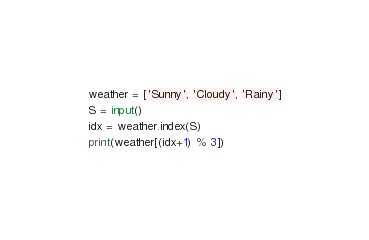<code> <loc_0><loc_0><loc_500><loc_500><_Python_>weather = ['Sunny', 'Cloudy', 'Rainy']
S = input()
idx = weather.index(S)
print(weather[(idx+1) % 3])</code> 